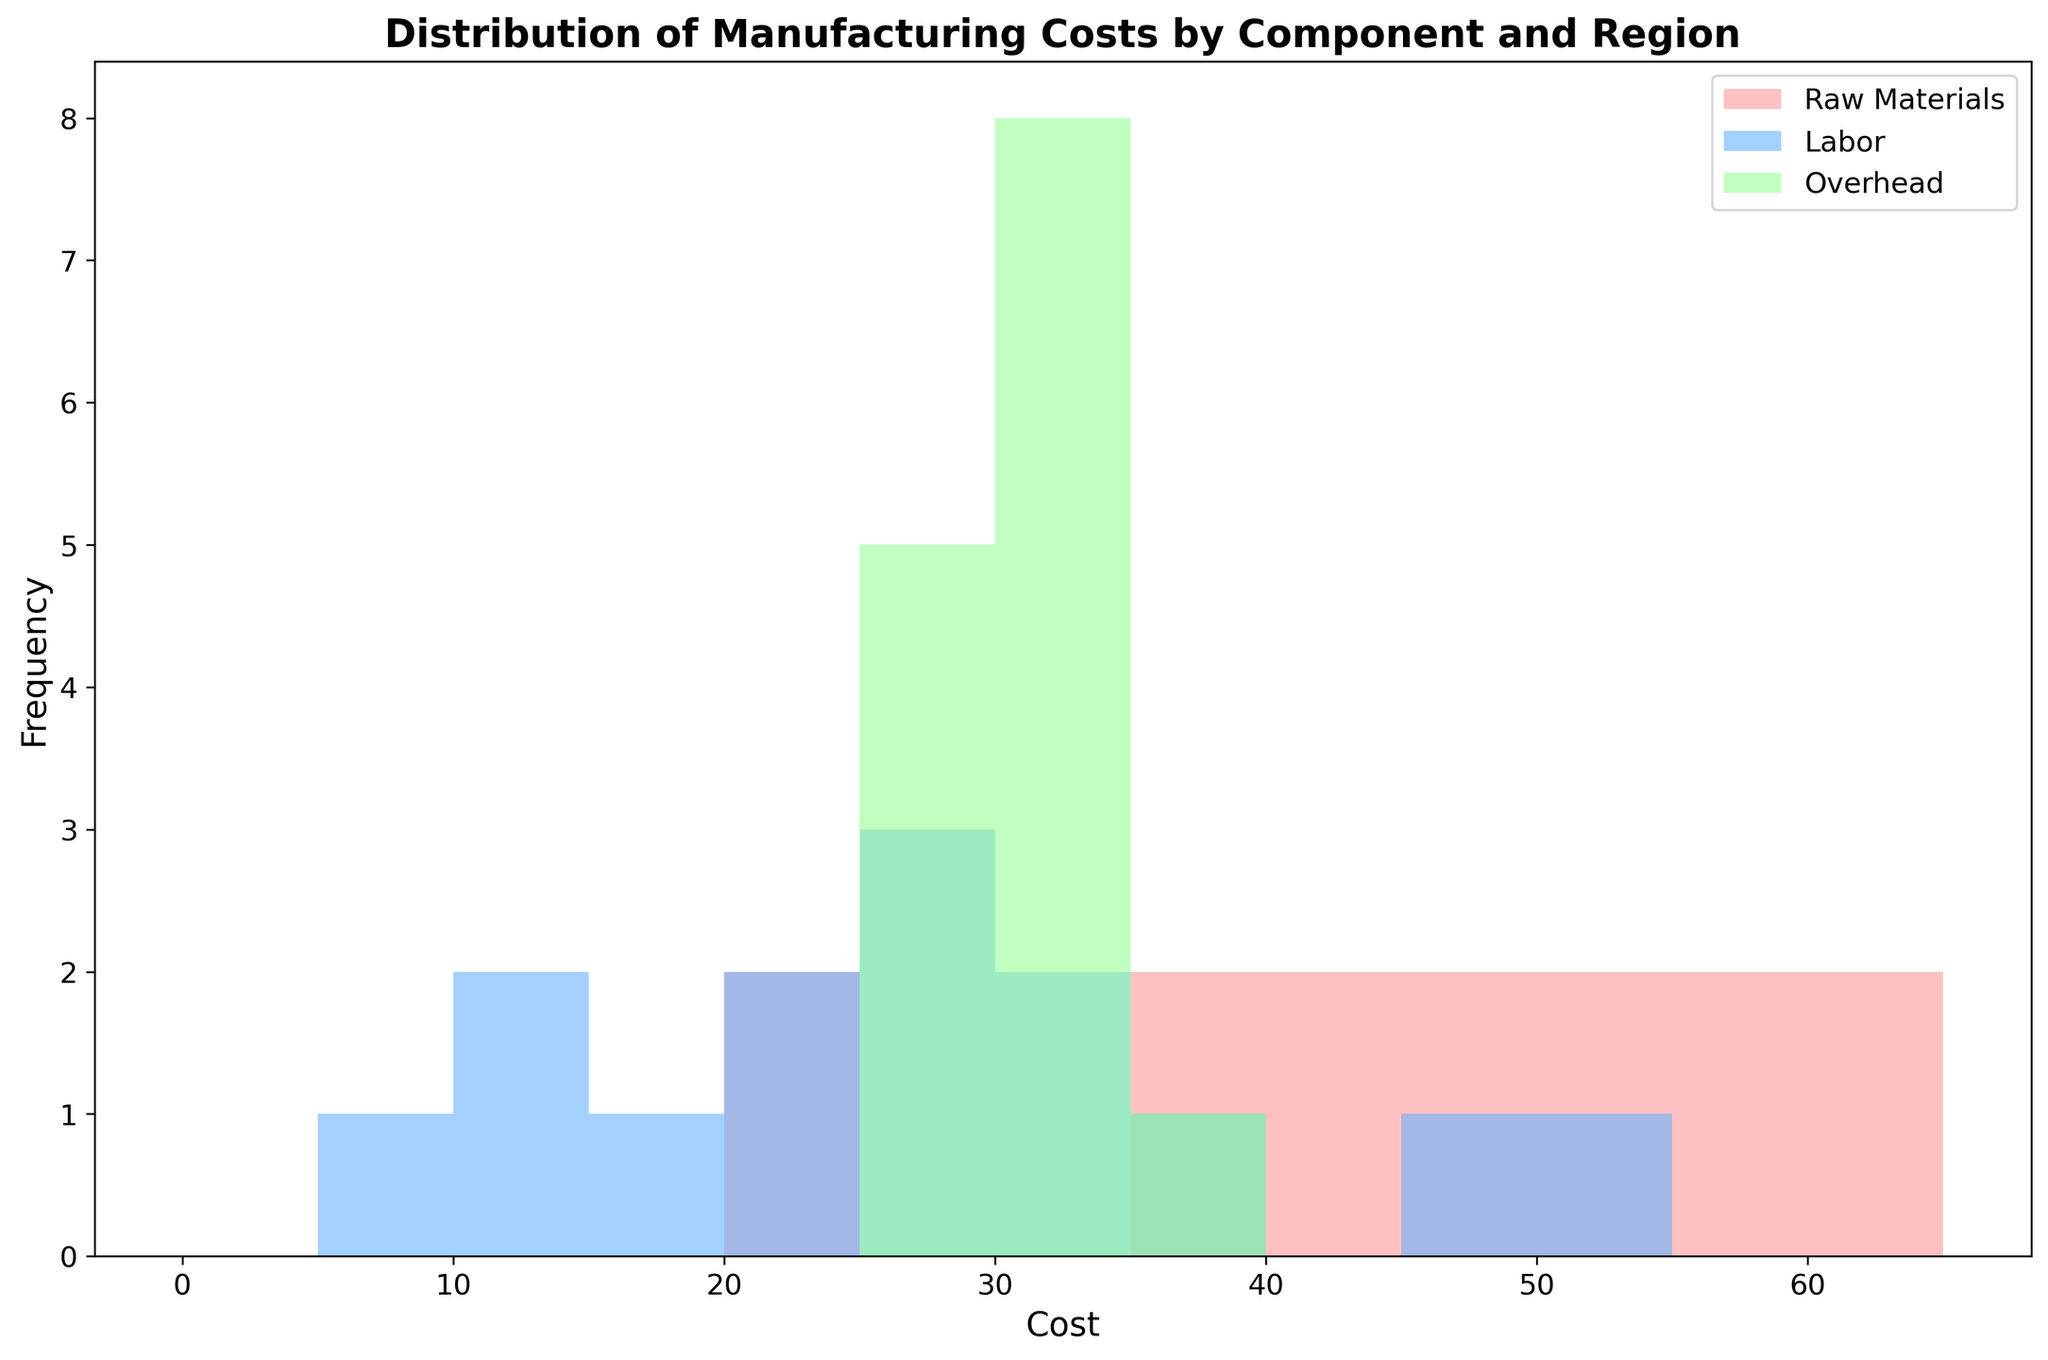What component has the highest frequency in the 35-40 cost range? The histogram shows bars representing the frequency of different components in specified cost ranges. Identify the bar in the 35-40 range and the component with the tallest bar.
Answer: Labor Which component's cost is most evenly distributed across regions? Look for the histogram that has relatively uniform bar heights across all cost ranges, indicating even distribution.
Answer: Overhead What region has the highest frequency of raw material costs? Identify the color representing 'Raw Materials' and find the region with the tallest bar in any cost range.
Answer: Africa How does the frequency of labor costs in the 20-25 range compare to the 25-30 range? Compare the heights of the bars in the ranges 20-25 and 25-30 for the 'Labor' component.
Answer: Higher in 25-30 Among all components, which has the highest frequency in the 60-65 cost range? Locate the bars in the 60-65 cost range and identify the component with the tallest bar in that range.
Answer: Raw Materials Compare the frequency of manufacturing costs of raw materials between 40-45 and 45-50 ranges. Locate the bars for the 'Raw Materials' component in the cost ranges 40-45 and 45-50 and compare their heights.
Answer: Higher in 45-50 Which component shows the most number of regions with costs in the 30-35 range? Identify the bars in the 30-35 range and count the number of regions represented for each component.
Answer: Overhead What is the cost range where overhead costs occur most frequently? Identify the highest bar among the bars representing 'Overhead' costs and note the corresponding cost range.
Answer: 25-30 How frequently do raw material costs fall into the 50-55 range? Look at the bar heights for the 'Raw Materials' component in the 50-55 cost range and determine the frequency.
Answer: High Which component's costs show the least variation across the cost ranges? Identify the component with the most bars of similar height across different cost ranges, indicating low variation.
Answer: Overhead 